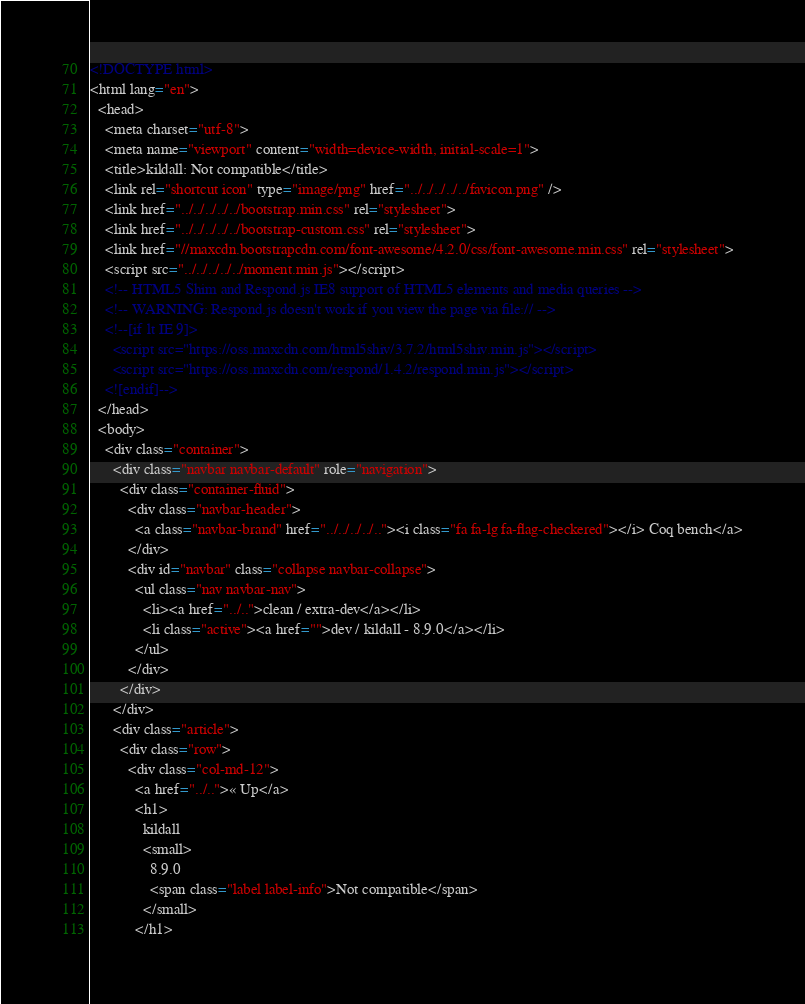Convert code to text. <code><loc_0><loc_0><loc_500><loc_500><_HTML_><!DOCTYPE html>
<html lang="en">
  <head>
    <meta charset="utf-8">
    <meta name="viewport" content="width=device-width, initial-scale=1">
    <title>kildall: Not compatible</title>
    <link rel="shortcut icon" type="image/png" href="../../../../../favicon.png" />
    <link href="../../../../../bootstrap.min.css" rel="stylesheet">
    <link href="../../../../../bootstrap-custom.css" rel="stylesheet">
    <link href="//maxcdn.bootstrapcdn.com/font-awesome/4.2.0/css/font-awesome.min.css" rel="stylesheet">
    <script src="../../../../../moment.min.js"></script>
    <!-- HTML5 Shim and Respond.js IE8 support of HTML5 elements and media queries -->
    <!-- WARNING: Respond.js doesn't work if you view the page via file:// -->
    <!--[if lt IE 9]>
      <script src="https://oss.maxcdn.com/html5shiv/3.7.2/html5shiv.min.js"></script>
      <script src="https://oss.maxcdn.com/respond/1.4.2/respond.min.js"></script>
    <![endif]-->
  </head>
  <body>
    <div class="container">
      <div class="navbar navbar-default" role="navigation">
        <div class="container-fluid">
          <div class="navbar-header">
            <a class="navbar-brand" href="../../../../.."><i class="fa fa-lg fa-flag-checkered"></i> Coq bench</a>
          </div>
          <div id="navbar" class="collapse navbar-collapse">
            <ul class="nav navbar-nav">
              <li><a href="../..">clean / extra-dev</a></li>
              <li class="active"><a href="">dev / kildall - 8.9.0</a></li>
            </ul>
          </div>
        </div>
      </div>
      <div class="article">
        <div class="row">
          <div class="col-md-12">
            <a href="../..">« Up</a>
            <h1>
              kildall
              <small>
                8.9.0
                <span class="label label-info">Not compatible</span>
              </small>
            </h1></code> 